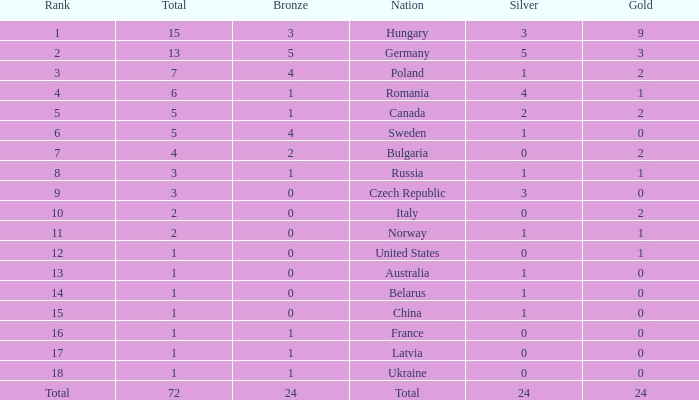How many golds have 3 as the rank, with a total greater than 7? 0.0. 